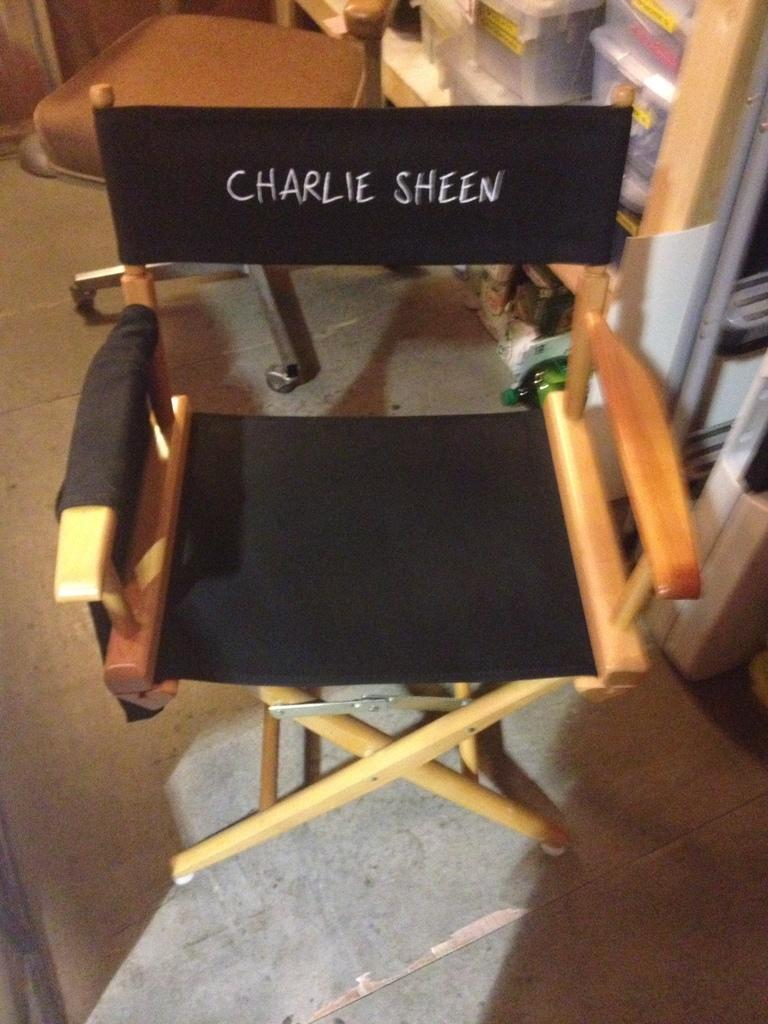What type of chair is in the image? The chair appears to be a stool with wheels. What is written on the chair? There is a name written on the chair. Where are the boxes located in the image? The boxes are placed in a rack. What can be seen on the floor in the image? The floor is visible in the image. Can you see any wings on the chair in the image? There are no wings present on the chair in the image. What was the afterthought when designing the chair? The provided facts do not mention any afterthoughts in the design of the chair. 